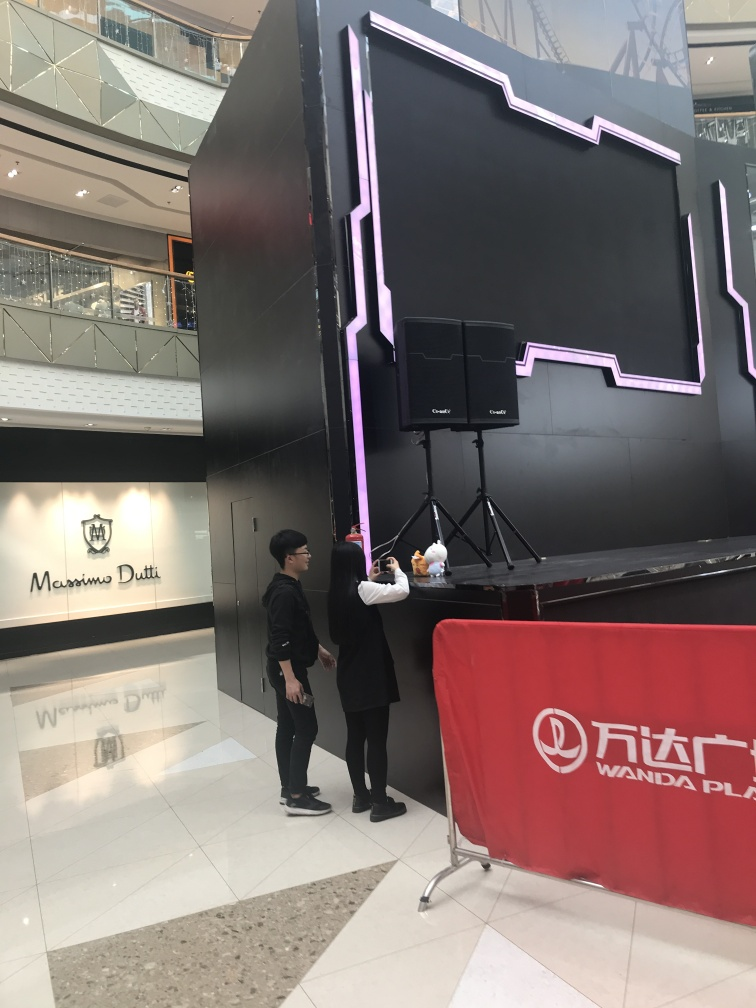What is happening in this image? The image shows two individuals standing in front of a large, irregularly shaped black structure with pink neon lights. One person seems to be taking a photo of the other with a mobile device. They are situated in a spacious indoor area, likely a mall, indicated by the reflective flooring and a shop sign in the background. 